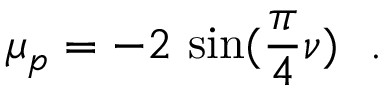Convert formula to latex. <formula><loc_0><loc_0><loc_500><loc_500>\mu _ { p } = - 2 \, \sin ( \frac { \pi } { 4 } \nu ) .</formula> 